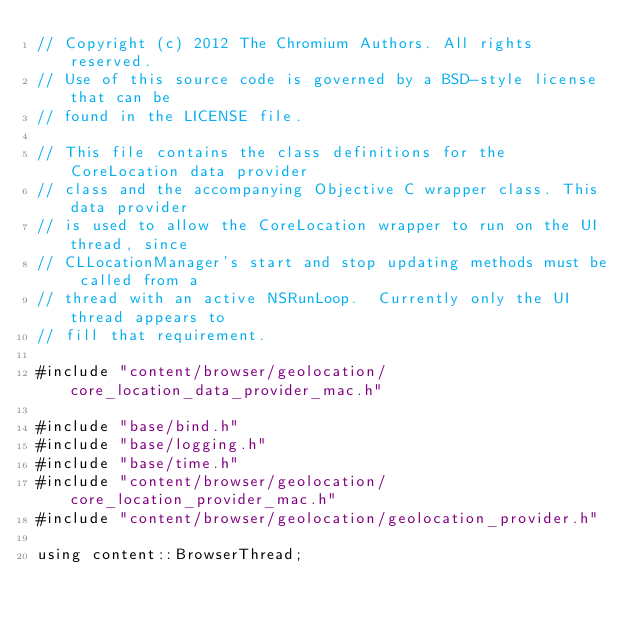Convert code to text. <code><loc_0><loc_0><loc_500><loc_500><_ObjectiveC_>// Copyright (c) 2012 The Chromium Authors. All rights reserved.
// Use of this source code is governed by a BSD-style license that can be
// found in the LICENSE file.

// This file contains the class definitions for the CoreLocation data provider
// class and the accompanying Objective C wrapper class. This data provider
// is used to allow the CoreLocation wrapper to run on the UI thread, since
// CLLocationManager's start and stop updating methods must be called from a
// thread with an active NSRunLoop.  Currently only the UI thread appears to
// fill that requirement.

#include "content/browser/geolocation/core_location_data_provider_mac.h"

#include "base/bind.h"
#include "base/logging.h"
#include "base/time.h"
#include "content/browser/geolocation/core_location_provider_mac.h"
#include "content/browser/geolocation/geolocation_provider.h"

using content::BrowserThread;
</code> 